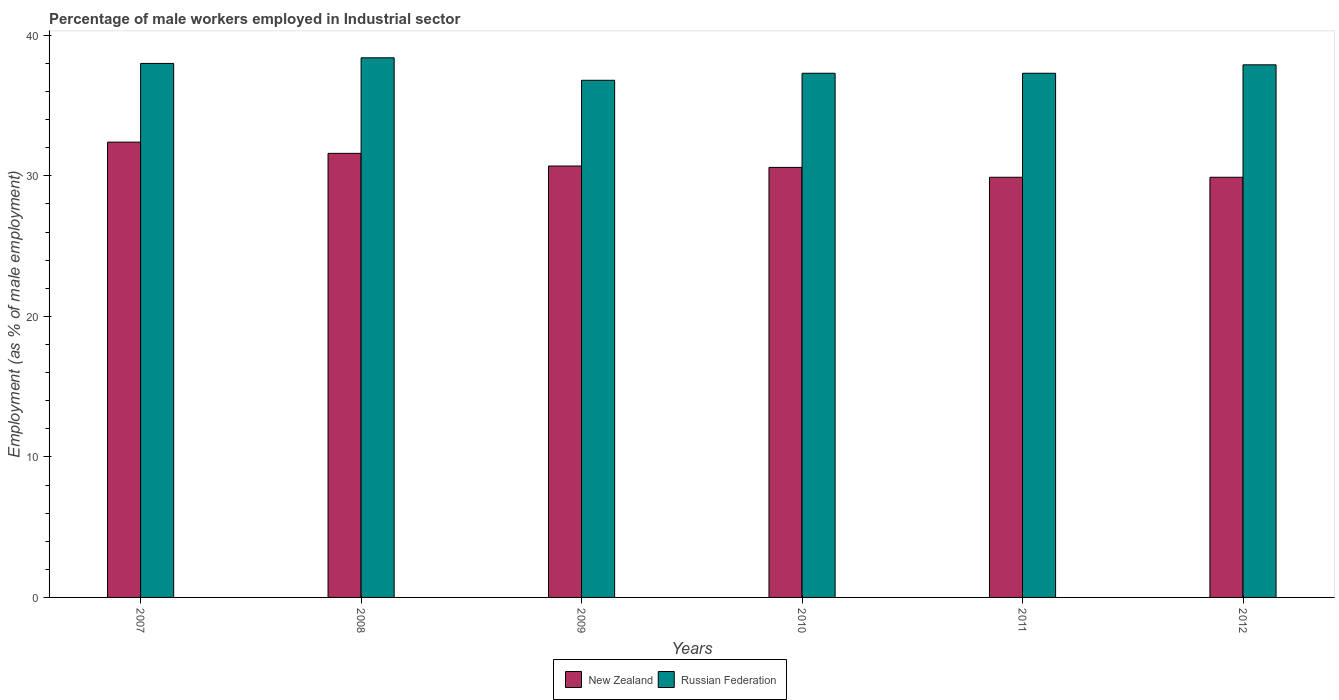How many different coloured bars are there?
Ensure brevity in your answer.  2. How many groups of bars are there?
Your response must be concise. 6. How many bars are there on the 1st tick from the right?
Offer a very short reply. 2. What is the label of the 5th group of bars from the left?
Keep it short and to the point. 2011. In how many cases, is the number of bars for a given year not equal to the number of legend labels?
Your response must be concise. 0. What is the percentage of male workers employed in Industrial sector in Russian Federation in 2008?
Your response must be concise. 38.4. Across all years, what is the maximum percentage of male workers employed in Industrial sector in New Zealand?
Make the answer very short. 32.4. Across all years, what is the minimum percentage of male workers employed in Industrial sector in Russian Federation?
Offer a very short reply. 36.8. What is the total percentage of male workers employed in Industrial sector in Russian Federation in the graph?
Your answer should be compact. 225.7. What is the difference between the percentage of male workers employed in Industrial sector in New Zealand in 2010 and that in 2012?
Provide a succinct answer. 0.7. What is the difference between the percentage of male workers employed in Industrial sector in Russian Federation in 2008 and the percentage of male workers employed in Industrial sector in New Zealand in 2010?
Offer a terse response. 7.8. What is the average percentage of male workers employed in Industrial sector in New Zealand per year?
Your response must be concise. 30.85. In the year 2010, what is the difference between the percentage of male workers employed in Industrial sector in Russian Federation and percentage of male workers employed in Industrial sector in New Zealand?
Ensure brevity in your answer.  6.7. In how many years, is the percentage of male workers employed in Industrial sector in Russian Federation greater than 12 %?
Provide a succinct answer. 6. What is the ratio of the percentage of male workers employed in Industrial sector in Russian Federation in 2009 to that in 2011?
Offer a terse response. 0.99. Is the percentage of male workers employed in Industrial sector in New Zealand in 2009 less than that in 2010?
Offer a very short reply. No. What is the difference between the highest and the second highest percentage of male workers employed in Industrial sector in Russian Federation?
Your answer should be very brief. 0.4. What is the difference between the highest and the lowest percentage of male workers employed in Industrial sector in Russian Federation?
Offer a very short reply. 1.6. What does the 1st bar from the left in 2007 represents?
Keep it short and to the point. New Zealand. What does the 2nd bar from the right in 2008 represents?
Provide a short and direct response. New Zealand. How many bars are there?
Offer a very short reply. 12. Are all the bars in the graph horizontal?
Provide a succinct answer. No. What is the difference between two consecutive major ticks on the Y-axis?
Offer a terse response. 10. Are the values on the major ticks of Y-axis written in scientific E-notation?
Keep it short and to the point. No. Does the graph contain any zero values?
Your answer should be very brief. No. Does the graph contain grids?
Your answer should be compact. No. Where does the legend appear in the graph?
Your answer should be very brief. Bottom center. How are the legend labels stacked?
Keep it short and to the point. Horizontal. What is the title of the graph?
Provide a succinct answer. Percentage of male workers employed in Industrial sector. Does "Saudi Arabia" appear as one of the legend labels in the graph?
Your answer should be very brief. No. What is the label or title of the X-axis?
Provide a succinct answer. Years. What is the label or title of the Y-axis?
Provide a succinct answer. Employment (as % of male employment). What is the Employment (as % of male employment) in New Zealand in 2007?
Keep it short and to the point. 32.4. What is the Employment (as % of male employment) in Russian Federation in 2007?
Offer a terse response. 38. What is the Employment (as % of male employment) of New Zealand in 2008?
Offer a terse response. 31.6. What is the Employment (as % of male employment) of Russian Federation in 2008?
Your response must be concise. 38.4. What is the Employment (as % of male employment) in New Zealand in 2009?
Make the answer very short. 30.7. What is the Employment (as % of male employment) in Russian Federation in 2009?
Keep it short and to the point. 36.8. What is the Employment (as % of male employment) of New Zealand in 2010?
Keep it short and to the point. 30.6. What is the Employment (as % of male employment) of Russian Federation in 2010?
Provide a short and direct response. 37.3. What is the Employment (as % of male employment) of New Zealand in 2011?
Your response must be concise. 29.9. What is the Employment (as % of male employment) of Russian Federation in 2011?
Keep it short and to the point. 37.3. What is the Employment (as % of male employment) of New Zealand in 2012?
Ensure brevity in your answer.  29.9. What is the Employment (as % of male employment) of Russian Federation in 2012?
Ensure brevity in your answer.  37.9. Across all years, what is the maximum Employment (as % of male employment) in New Zealand?
Your answer should be very brief. 32.4. Across all years, what is the maximum Employment (as % of male employment) of Russian Federation?
Offer a very short reply. 38.4. Across all years, what is the minimum Employment (as % of male employment) in New Zealand?
Your answer should be very brief. 29.9. Across all years, what is the minimum Employment (as % of male employment) in Russian Federation?
Offer a very short reply. 36.8. What is the total Employment (as % of male employment) in New Zealand in the graph?
Provide a short and direct response. 185.1. What is the total Employment (as % of male employment) of Russian Federation in the graph?
Keep it short and to the point. 225.7. What is the difference between the Employment (as % of male employment) of New Zealand in 2007 and that in 2009?
Provide a short and direct response. 1.7. What is the difference between the Employment (as % of male employment) of Russian Federation in 2007 and that in 2009?
Your answer should be very brief. 1.2. What is the difference between the Employment (as % of male employment) of Russian Federation in 2007 and that in 2010?
Provide a short and direct response. 0.7. What is the difference between the Employment (as % of male employment) of Russian Federation in 2007 and that in 2012?
Your response must be concise. 0.1. What is the difference between the Employment (as % of male employment) in New Zealand in 2008 and that in 2012?
Your answer should be very brief. 1.7. What is the difference between the Employment (as % of male employment) of Russian Federation in 2009 and that in 2011?
Keep it short and to the point. -0.5. What is the difference between the Employment (as % of male employment) in Russian Federation in 2009 and that in 2012?
Provide a succinct answer. -1.1. What is the difference between the Employment (as % of male employment) of New Zealand in 2010 and that in 2011?
Keep it short and to the point. 0.7. What is the difference between the Employment (as % of male employment) in Russian Federation in 2010 and that in 2011?
Keep it short and to the point. 0. What is the difference between the Employment (as % of male employment) in New Zealand in 2007 and the Employment (as % of male employment) in Russian Federation in 2009?
Make the answer very short. -4.4. What is the difference between the Employment (as % of male employment) of New Zealand in 2007 and the Employment (as % of male employment) of Russian Federation in 2011?
Make the answer very short. -4.9. What is the difference between the Employment (as % of male employment) in New Zealand in 2008 and the Employment (as % of male employment) in Russian Federation in 2009?
Your answer should be very brief. -5.2. What is the difference between the Employment (as % of male employment) of New Zealand in 2008 and the Employment (as % of male employment) of Russian Federation in 2011?
Make the answer very short. -5.7. What is the difference between the Employment (as % of male employment) in New Zealand in 2009 and the Employment (as % of male employment) in Russian Federation in 2010?
Provide a succinct answer. -6.6. What is the difference between the Employment (as % of male employment) of New Zealand in 2010 and the Employment (as % of male employment) of Russian Federation in 2012?
Offer a terse response. -7.3. What is the difference between the Employment (as % of male employment) in New Zealand in 2011 and the Employment (as % of male employment) in Russian Federation in 2012?
Your answer should be compact. -8. What is the average Employment (as % of male employment) in New Zealand per year?
Your answer should be very brief. 30.85. What is the average Employment (as % of male employment) in Russian Federation per year?
Provide a short and direct response. 37.62. In the year 2008, what is the difference between the Employment (as % of male employment) in New Zealand and Employment (as % of male employment) in Russian Federation?
Make the answer very short. -6.8. In the year 2011, what is the difference between the Employment (as % of male employment) of New Zealand and Employment (as % of male employment) of Russian Federation?
Offer a very short reply. -7.4. What is the ratio of the Employment (as % of male employment) of New Zealand in 2007 to that in 2008?
Keep it short and to the point. 1.03. What is the ratio of the Employment (as % of male employment) of New Zealand in 2007 to that in 2009?
Make the answer very short. 1.06. What is the ratio of the Employment (as % of male employment) in Russian Federation in 2007 to that in 2009?
Your answer should be compact. 1.03. What is the ratio of the Employment (as % of male employment) of New Zealand in 2007 to that in 2010?
Offer a very short reply. 1.06. What is the ratio of the Employment (as % of male employment) of Russian Federation in 2007 to that in 2010?
Make the answer very short. 1.02. What is the ratio of the Employment (as % of male employment) of New Zealand in 2007 to that in 2011?
Your answer should be very brief. 1.08. What is the ratio of the Employment (as % of male employment) of Russian Federation in 2007 to that in 2011?
Your response must be concise. 1.02. What is the ratio of the Employment (as % of male employment) of New Zealand in 2007 to that in 2012?
Your answer should be compact. 1.08. What is the ratio of the Employment (as % of male employment) of Russian Federation in 2007 to that in 2012?
Offer a terse response. 1. What is the ratio of the Employment (as % of male employment) of New Zealand in 2008 to that in 2009?
Provide a succinct answer. 1.03. What is the ratio of the Employment (as % of male employment) in Russian Federation in 2008 to that in 2009?
Your answer should be very brief. 1.04. What is the ratio of the Employment (as % of male employment) of New Zealand in 2008 to that in 2010?
Keep it short and to the point. 1.03. What is the ratio of the Employment (as % of male employment) in Russian Federation in 2008 to that in 2010?
Your answer should be very brief. 1.03. What is the ratio of the Employment (as % of male employment) of New Zealand in 2008 to that in 2011?
Your response must be concise. 1.06. What is the ratio of the Employment (as % of male employment) in Russian Federation in 2008 to that in 2011?
Your response must be concise. 1.03. What is the ratio of the Employment (as % of male employment) in New Zealand in 2008 to that in 2012?
Offer a terse response. 1.06. What is the ratio of the Employment (as % of male employment) of Russian Federation in 2008 to that in 2012?
Offer a terse response. 1.01. What is the ratio of the Employment (as % of male employment) in New Zealand in 2009 to that in 2010?
Keep it short and to the point. 1. What is the ratio of the Employment (as % of male employment) in Russian Federation in 2009 to that in 2010?
Give a very brief answer. 0.99. What is the ratio of the Employment (as % of male employment) of New Zealand in 2009 to that in 2011?
Offer a very short reply. 1.03. What is the ratio of the Employment (as % of male employment) in Russian Federation in 2009 to that in 2011?
Your answer should be very brief. 0.99. What is the ratio of the Employment (as % of male employment) in New Zealand in 2009 to that in 2012?
Give a very brief answer. 1.03. What is the ratio of the Employment (as % of male employment) of New Zealand in 2010 to that in 2011?
Make the answer very short. 1.02. What is the ratio of the Employment (as % of male employment) of New Zealand in 2010 to that in 2012?
Ensure brevity in your answer.  1.02. What is the ratio of the Employment (as % of male employment) of Russian Federation in 2010 to that in 2012?
Ensure brevity in your answer.  0.98. What is the ratio of the Employment (as % of male employment) in New Zealand in 2011 to that in 2012?
Keep it short and to the point. 1. What is the ratio of the Employment (as % of male employment) in Russian Federation in 2011 to that in 2012?
Offer a terse response. 0.98. What is the difference between the highest and the second highest Employment (as % of male employment) in Russian Federation?
Ensure brevity in your answer.  0.4. What is the difference between the highest and the lowest Employment (as % of male employment) of New Zealand?
Provide a succinct answer. 2.5. What is the difference between the highest and the lowest Employment (as % of male employment) in Russian Federation?
Provide a short and direct response. 1.6. 